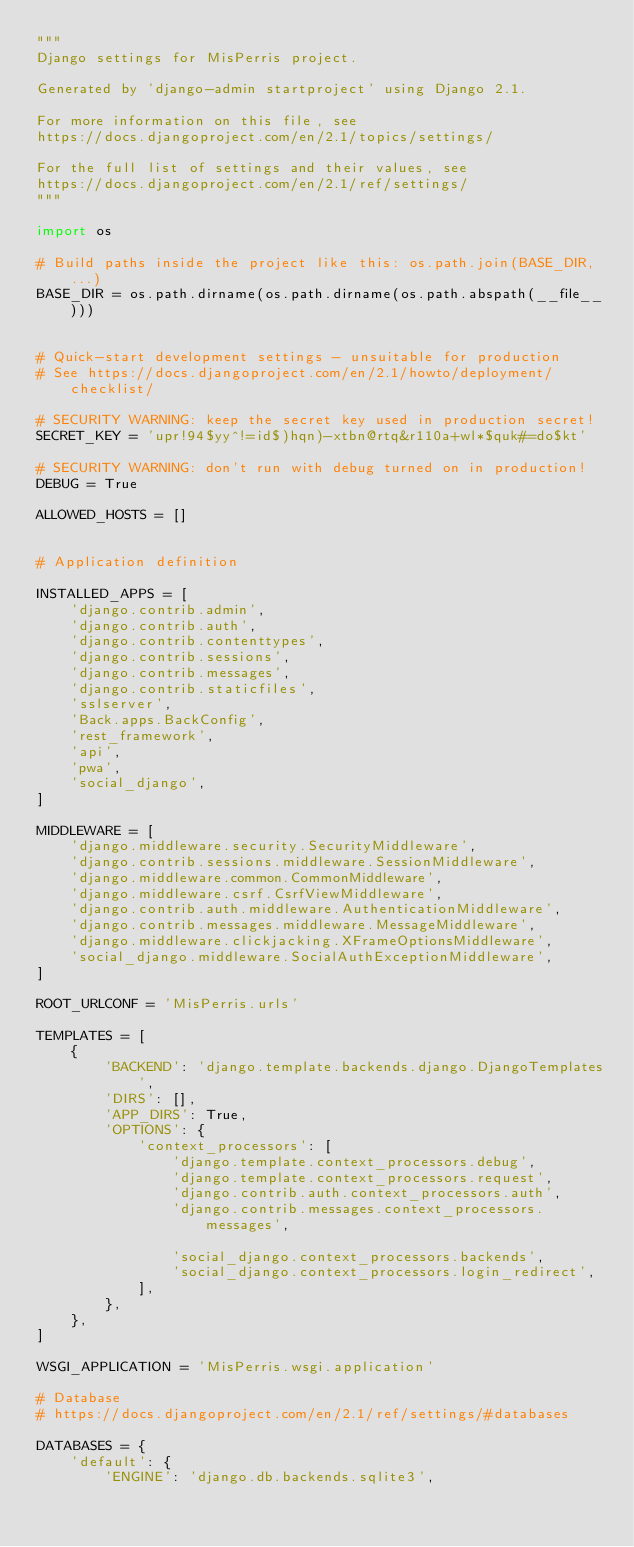Convert code to text. <code><loc_0><loc_0><loc_500><loc_500><_Python_>"""
Django settings for MisPerris project.

Generated by 'django-admin startproject' using Django 2.1.

For more information on this file, see
https://docs.djangoproject.com/en/2.1/topics/settings/

For the full list of settings and their values, see
https://docs.djangoproject.com/en/2.1/ref/settings/
"""

import os

# Build paths inside the project like this: os.path.join(BASE_DIR, ...)
BASE_DIR = os.path.dirname(os.path.dirname(os.path.abspath(__file__)))


# Quick-start development settings - unsuitable for production
# See https://docs.djangoproject.com/en/2.1/howto/deployment/checklist/

# SECURITY WARNING: keep the secret key used in production secret!
SECRET_KEY = 'upr!94$yy^!=id$)hqn)-xtbn@rtq&r110a+wl*$quk#=do$kt'

# SECURITY WARNING: don't run with debug turned on in production!
DEBUG = True

ALLOWED_HOSTS = []


# Application definition

INSTALLED_APPS = [
    'django.contrib.admin',
    'django.contrib.auth',
    'django.contrib.contenttypes',
    'django.contrib.sessions',
    'django.contrib.messages',
    'django.contrib.staticfiles',
    'sslserver',
    'Back.apps.BackConfig',
    'rest_framework',
    'api',
    'pwa',
    'social_django',
]

MIDDLEWARE = [
    'django.middleware.security.SecurityMiddleware',
    'django.contrib.sessions.middleware.SessionMiddleware',
    'django.middleware.common.CommonMiddleware',
    'django.middleware.csrf.CsrfViewMiddleware',
    'django.contrib.auth.middleware.AuthenticationMiddleware',
    'django.contrib.messages.middleware.MessageMiddleware',
    'django.middleware.clickjacking.XFrameOptionsMiddleware',
    'social_django.middleware.SocialAuthExceptionMiddleware',
]

ROOT_URLCONF = 'MisPerris.urls'

TEMPLATES = [
    {
        'BACKEND': 'django.template.backends.django.DjangoTemplates',
        'DIRS': [],
        'APP_DIRS': True,
        'OPTIONS': {
            'context_processors': [
                'django.template.context_processors.debug',
                'django.template.context_processors.request',
                'django.contrib.auth.context_processors.auth',
                'django.contrib.messages.context_processors.messages',

                'social_django.context_processors.backends',
                'social_django.context_processors.login_redirect',
            ],
        },
    },
]

WSGI_APPLICATION = 'MisPerris.wsgi.application'

# Database
# https://docs.djangoproject.com/en/2.1/ref/settings/#databases

DATABASES = {
    'default': {
        'ENGINE': 'django.db.backends.sqlite3',</code> 